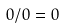Convert formula to latex. <formula><loc_0><loc_0><loc_500><loc_500>0 / 0 = 0</formula> 